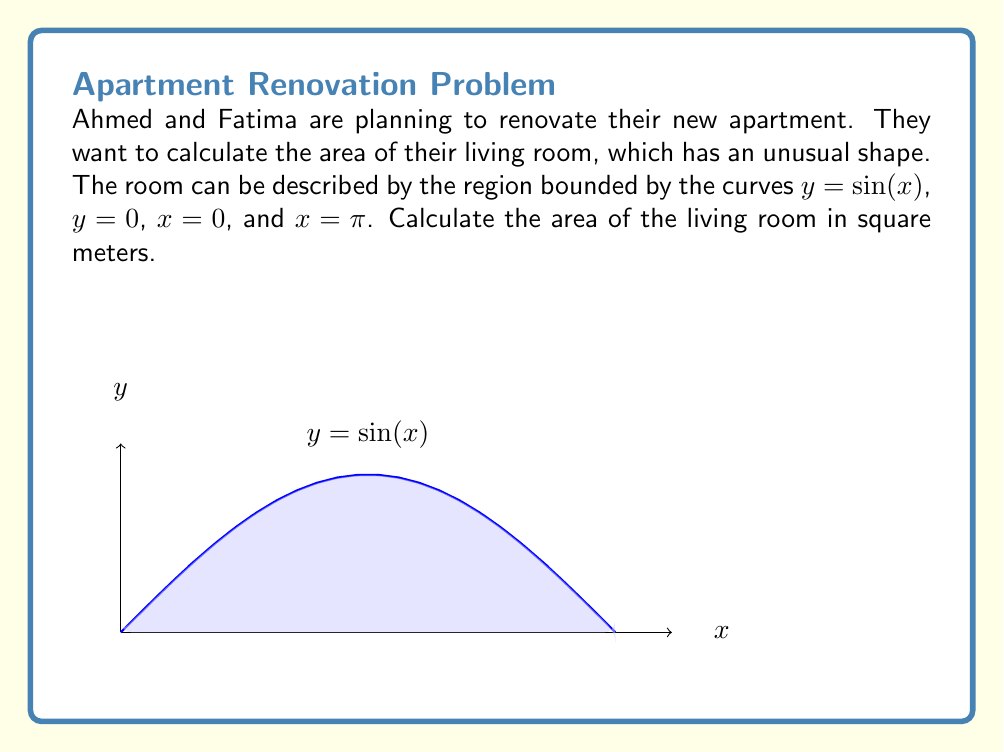Solve this math problem. To calculate the area of the living room, we need to use integration. The area is represented by the region under the curve $y = \sin(x)$ from $x = 0$ to $x = \pi$. We can follow these steps:

1) The formula for the area under a curve is:

   $$A = \int_{a}^{b} f(x) dx$$

   where $f(x)$ is the function, $a$ is the lower limit, and $b$ is the upper limit.

2) In this case, $f(x) = \sin(x)$, $a = 0$, and $b = \pi$. So our integral becomes:

   $$A = \int_{0}^{\pi} \sin(x) dx$$

3) To solve this, we need to use the antiderivative of $\sin(x)$, which is $-\cos(x)$. So:

   $$A = [-\cos(x)]_{0}^{\pi}$$

4) Now we evaluate this at the limits:

   $$A = [-\cos(\pi)] - [-\cos(0)]$$

5) We know that $\cos(\pi) = -1$ and $\cos(0) = 1$, so:

   $$A = [1] - [-1] = 1 + 1 = 2$$

6) Therefore, the area of the living room is 2 square meters.
Answer: 2 m² 